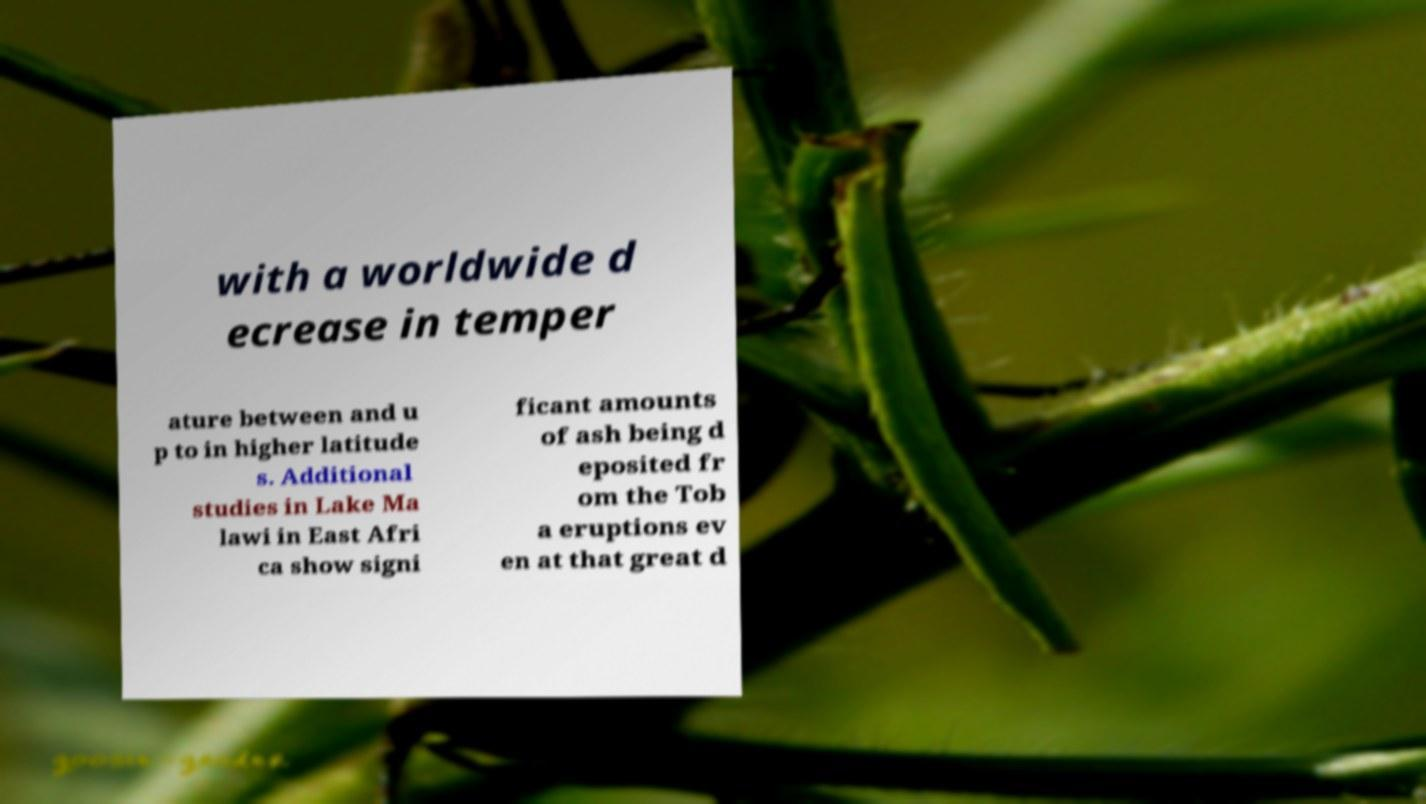Please read and relay the text visible in this image. What does it say? with a worldwide d ecrease in temper ature between and u p to in higher latitude s. Additional studies in Lake Ma lawi in East Afri ca show signi ficant amounts of ash being d eposited fr om the Tob a eruptions ev en at that great d 